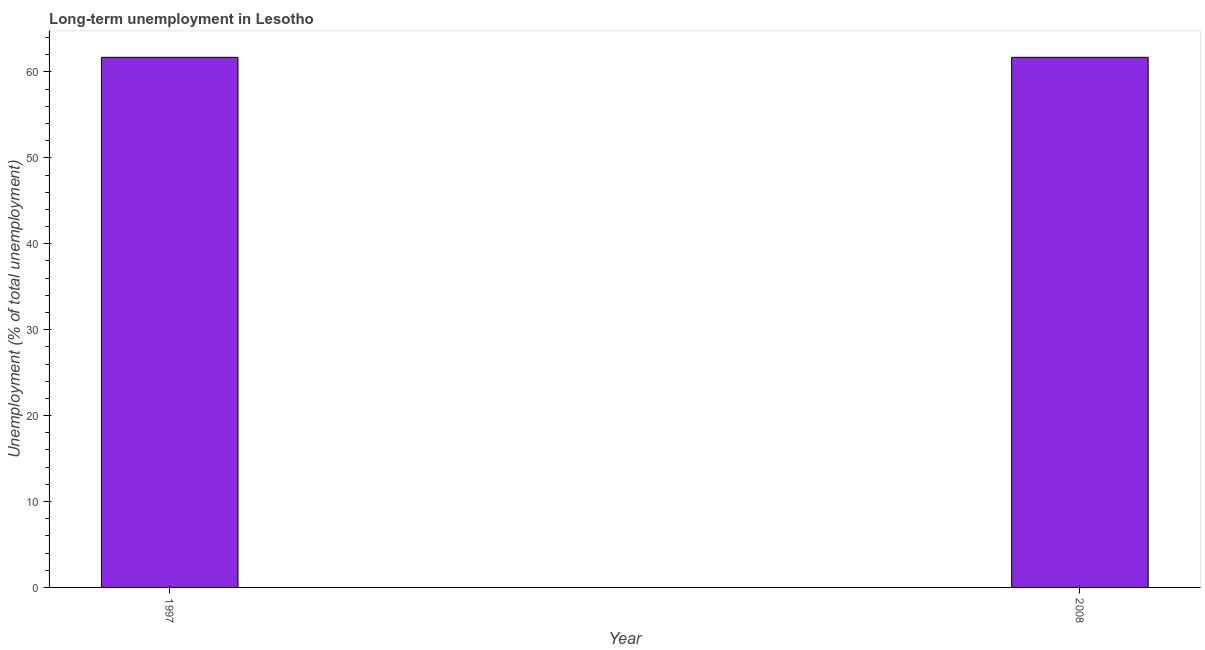Does the graph contain any zero values?
Offer a terse response. No. Does the graph contain grids?
Your answer should be very brief. No. What is the title of the graph?
Offer a terse response. Long-term unemployment in Lesotho. What is the label or title of the Y-axis?
Ensure brevity in your answer.  Unemployment (% of total unemployment). What is the long-term unemployment in 2008?
Give a very brief answer. 61.7. Across all years, what is the maximum long-term unemployment?
Offer a very short reply. 61.7. Across all years, what is the minimum long-term unemployment?
Keep it short and to the point. 61.7. In which year was the long-term unemployment maximum?
Make the answer very short. 1997. What is the sum of the long-term unemployment?
Your answer should be very brief. 123.4. What is the difference between the long-term unemployment in 1997 and 2008?
Your answer should be very brief. 0. What is the average long-term unemployment per year?
Your response must be concise. 61.7. What is the median long-term unemployment?
Your response must be concise. 61.7. In how many years, is the long-term unemployment greater than 24 %?
Offer a terse response. 2. Is the long-term unemployment in 1997 less than that in 2008?
Provide a short and direct response. No. In how many years, is the long-term unemployment greater than the average long-term unemployment taken over all years?
Ensure brevity in your answer.  0. How many bars are there?
Make the answer very short. 2. Are all the bars in the graph horizontal?
Keep it short and to the point. No. Are the values on the major ticks of Y-axis written in scientific E-notation?
Your answer should be very brief. No. What is the Unemployment (% of total unemployment) of 1997?
Your answer should be very brief. 61.7. What is the Unemployment (% of total unemployment) of 2008?
Ensure brevity in your answer.  61.7. What is the difference between the Unemployment (% of total unemployment) in 1997 and 2008?
Provide a short and direct response. 0. What is the ratio of the Unemployment (% of total unemployment) in 1997 to that in 2008?
Your answer should be very brief. 1. 